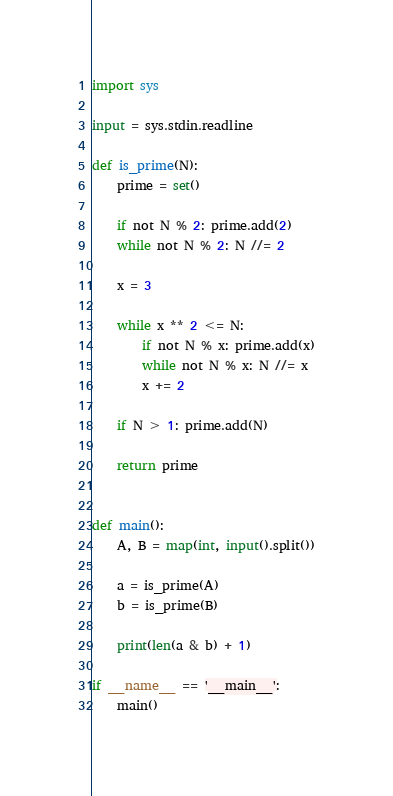Convert code to text. <code><loc_0><loc_0><loc_500><loc_500><_Python_>import sys

input = sys.stdin.readline

def is_prime(N):
    prime = set()
    
    if not N % 2: prime.add(2)
    while not N % 2: N //= 2
    
    x = 3
    
    while x ** 2 <= N:
        if not N % x: prime.add(x)
        while not N % x: N //= x
        x += 2
        
    if N > 1: prime.add(N)
    
    return prime


def main():
    A, B = map(int, input().split())
    
    a = is_prime(A)
    b = is_prime(B)
    
    print(len(a & b) + 1)

if __name__ == '__main__':
    main()</code> 